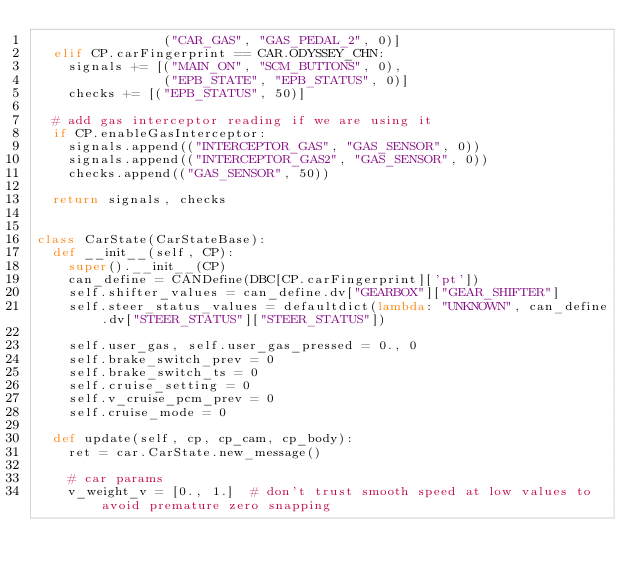<code> <loc_0><loc_0><loc_500><loc_500><_Python_>                ("CAR_GAS", "GAS_PEDAL_2", 0)]
  elif CP.carFingerprint == CAR.ODYSSEY_CHN:
    signals += [("MAIN_ON", "SCM_BUTTONS", 0),
                ("EPB_STATE", "EPB_STATUS", 0)]
    checks += [("EPB_STATUS", 50)]

  # add gas interceptor reading if we are using it
  if CP.enableGasInterceptor:
    signals.append(("INTERCEPTOR_GAS", "GAS_SENSOR", 0))
    signals.append(("INTERCEPTOR_GAS2", "GAS_SENSOR", 0))
    checks.append(("GAS_SENSOR", 50))

  return signals, checks


class CarState(CarStateBase):
  def __init__(self, CP):
    super().__init__(CP)
    can_define = CANDefine(DBC[CP.carFingerprint]['pt'])
    self.shifter_values = can_define.dv["GEARBOX"]["GEAR_SHIFTER"]
    self.steer_status_values = defaultdict(lambda: "UNKNOWN", can_define.dv["STEER_STATUS"]["STEER_STATUS"])

    self.user_gas, self.user_gas_pressed = 0., 0
    self.brake_switch_prev = 0
    self.brake_switch_ts = 0
    self.cruise_setting = 0
    self.v_cruise_pcm_prev = 0
    self.cruise_mode = 0

  def update(self, cp, cp_cam, cp_body):
    ret = car.CarState.new_message()

    # car params
    v_weight_v = [0., 1.]  # don't trust smooth speed at low values to avoid premature zero snapping</code> 